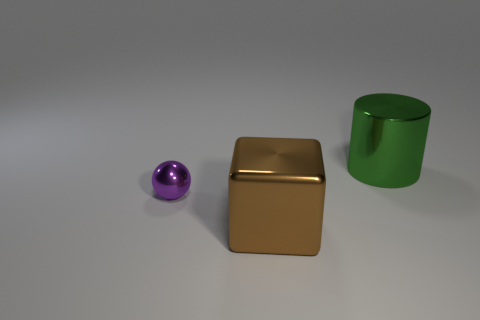Does the tiny purple object have the same shape as the big brown metallic thing?
Ensure brevity in your answer.  No. There is a purple thing that is made of the same material as the large green cylinder; what shape is it?
Provide a short and direct response. Sphere. What is the material of the object that is in front of the big metallic cylinder and to the right of the shiny sphere?
Provide a succinct answer. Metal. Is the color of the large metallic object that is in front of the small thing the same as the big metallic object that is behind the purple metallic thing?
Your answer should be compact. No. What number of brown metal cubes are behind the big metallic object that is left of the large metal thing that is behind the tiny purple sphere?
Ensure brevity in your answer.  0. How many metal things are both on the left side of the cylinder and to the right of the sphere?
Your response must be concise. 1. Are there more small metallic things in front of the tiny metal sphere than big brown cubes?
Make the answer very short. No. How many spheres have the same size as the brown metal thing?
Ensure brevity in your answer.  0. What number of big things are cyan metal objects or brown blocks?
Offer a terse response. 1. How many tiny shiny spheres are there?
Your response must be concise. 1. 